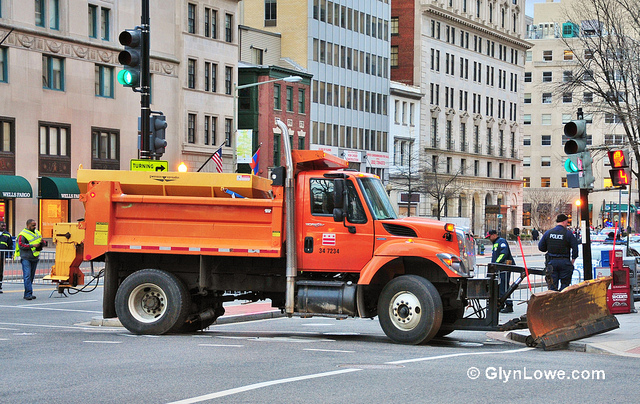Could you explore the historical significance of such trucks in urban settings? Municipal trucks like the one in the image have played a crucial role in maintaining urban infrastructure for decades. Historically, these vehicles emerged as cities expanded and the need for efficient and reliable road maintenance became paramount. Orange trucks, commonly used by city maintenance departments, are a staple in urban areas where they are employed to manage snow removal, street cleaning, and emergency response during adverse weather conditions. The development and evolution of such trucks have significantly contributed to improving public safety and urban livability. Can you tell me a creative story involving this truck? Once upon a time, in the bustling city of Metropolis, there was an orange truck named Blaze. Blaze was no ordinary truck; he possessed a magical plow blade that could clear not only snow but also obstacles of any kind. One winter, Metropolis faced an unprecedented snowstorm that buried the city streets under several feet of snow. The citizens were trapped in their homes, unable to go about their daily lives. Blaze, with his trusty plow blade, set out on a heroic journey to clear the streets. As he moved through the snow, his blade shimmered and sparkled, cutting through the thick ice with ease. Along the way, Blaze encountered various challenges, including giant snowdrifts and icy barricades. With determination and his magical blade, Blaze cleared the roads, freeing the trapped citizens and restoring normalcy to Metropolis. He became a legendary figure in the city, with stories of his bravery and magical abilities being passed down through generations. 